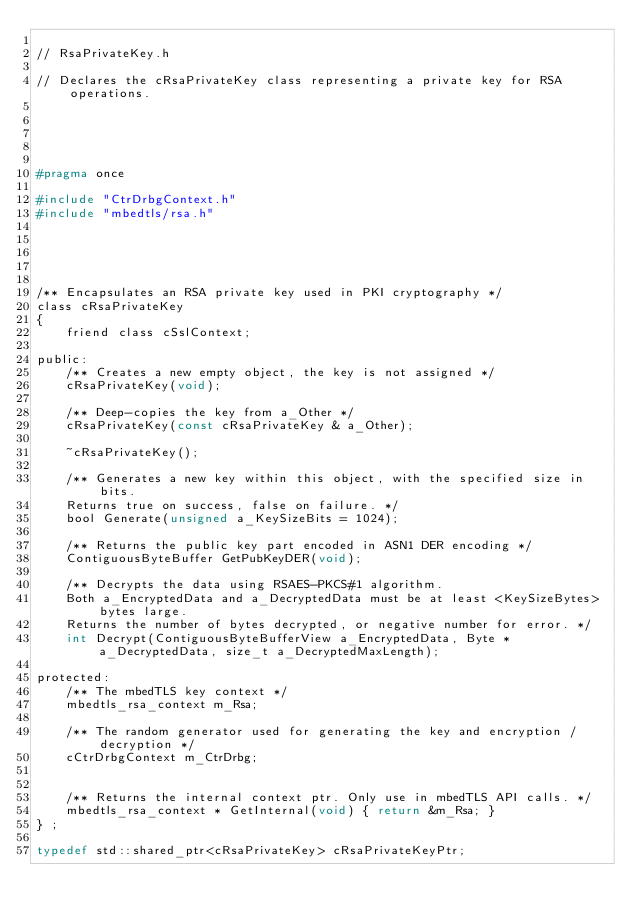Convert code to text. <code><loc_0><loc_0><loc_500><loc_500><_C_>
// RsaPrivateKey.h

// Declares the cRsaPrivateKey class representing a private key for RSA operations.





#pragma once

#include "CtrDrbgContext.h"
#include "mbedtls/rsa.h"





/** Encapsulates an RSA private key used in PKI cryptography */
class cRsaPrivateKey
{
	friend class cSslContext;

public:
	/** Creates a new empty object, the key is not assigned */
	cRsaPrivateKey(void);

	/** Deep-copies the key from a_Other */
	cRsaPrivateKey(const cRsaPrivateKey & a_Other);

	~cRsaPrivateKey();

	/** Generates a new key within this object, with the specified size in bits.
	Returns true on success, false on failure. */
	bool Generate(unsigned a_KeySizeBits = 1024);

	/** Returns the public key part encoded in ASN1 DER encoding */
	ContiguousByteBuffer GetPubKeyDER(void);

	/** Decrypts the data using RSAES-PKCS#1 algorithm.
	Both a_EncryptedData and a_DecryptedData must be at least <KeySizeBytes> bytes large.
	Returns the number of bytes decrypted, or negative number for error. */
	int Decrypt(ContiguousByteBufferView a_EncryptedData, Byte * a_DecryptedData, size_t a_DecryptedMaxLength);

protected:
	/** The mbedTLS key context */
	mbedtls_rsa_context m_Rsa;

	/** The random generator used for generating the key and encryption / decryption */
	cCtrDrbgContext m_CtrDrbg;


	/** Returns the internal context ptr. Only use in mbedTLS API calls. */
	mbedtls_rsa_context * GetInternal(void) { return &m_Rsa; }
} ;

typedef std::shared_ptr<cRsaPrivateKey> cRsaPrivateKeyPtr;





</code> 